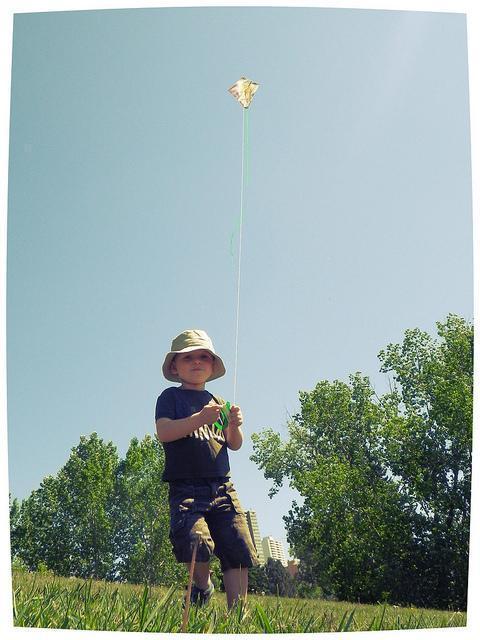How many people can be seen?
Give a very brief answer. 1. 